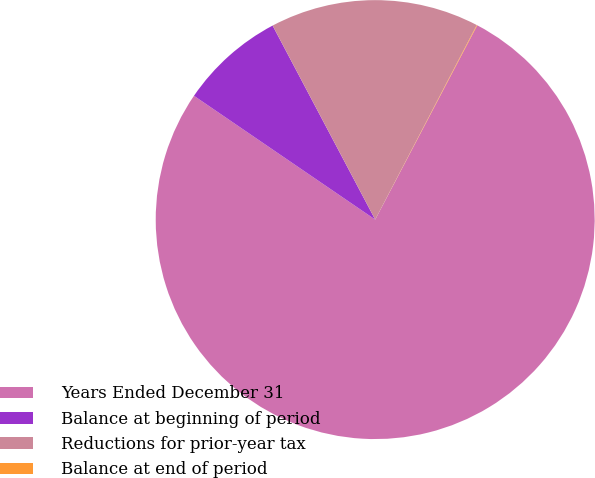Convert chart. <chart><loc_0><loc_0><loc_500><loc_500><pie_chart><fcel>Years Ended December 31<fcel>Balance at beginning of period<fcel>Reductions for prior-year tax<fcel>Balance at end of period<nl><fcel>76.84%<fcel>7.72%<fcel>15.4%<fcel>0.04%<nl></chart> 